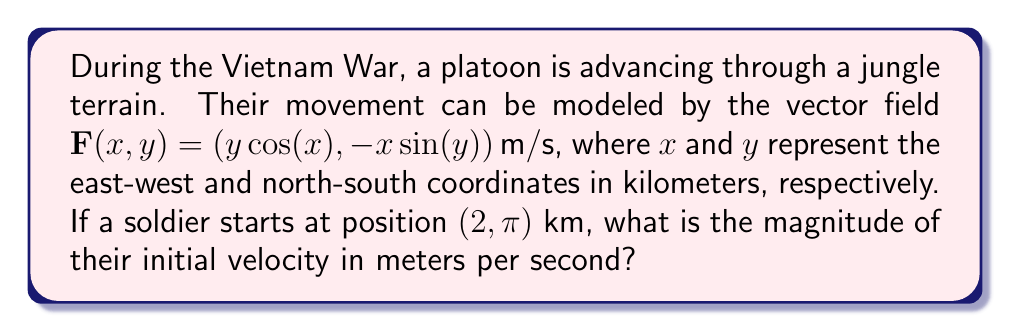Give your solution to this math problem. To solve this problem, we need to follow these steps:

1) The vector field $\mathbf{F}(x,y) = (y\cos(x), -x\sin(y))\,\text{m/s}$ gives us the velocity vector at any point $(x,y)$.

2) We need to find the velocity vector at the starting position $(2, \pi)$ km. Let's call this $\mathbf{v}$:

   $\mathbf{v} = \mathbf{F}(2, \pi) = (\pi\cos(2), -2\sin(\pi))\,\text{m/s}$

3) Simplify:
   - $\cos(2) \approx -0.4161$
   - $\sin(\pi) = 0$

   So, $\mathbf{v} \approx (-1.3079, 0)\,\text{m/s}$

4) To find the magnitude of this velocity vector, we use the formula:

   $\|\mathbf{v}\| = \sqrt{v_x^2 + v_y^2}$

   where $v_x$ and $v_y$ are the x and y components of $\mathbf{v}$.

5) Substituting our values:

   $\|\mathbf{v}\| = \sqrt{(-1.3079)^2 + 0^2} \approx 1.3079\,\text{m/s}$

Therefore, the initial velocity of the soldier is approximately 1.3079 m/s.
Answer: $1.3079\,\text{m/s}$ (rounded to 4 decimal places) 